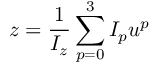Convert formula to latex. <formula><loc_0><loc_0><loc_500><loc_500>z = \frac { 1 } { I _ { z } } \sum _ { p = 0 } ^ { 3 } I _ { p } u ^ { p }</formula> 